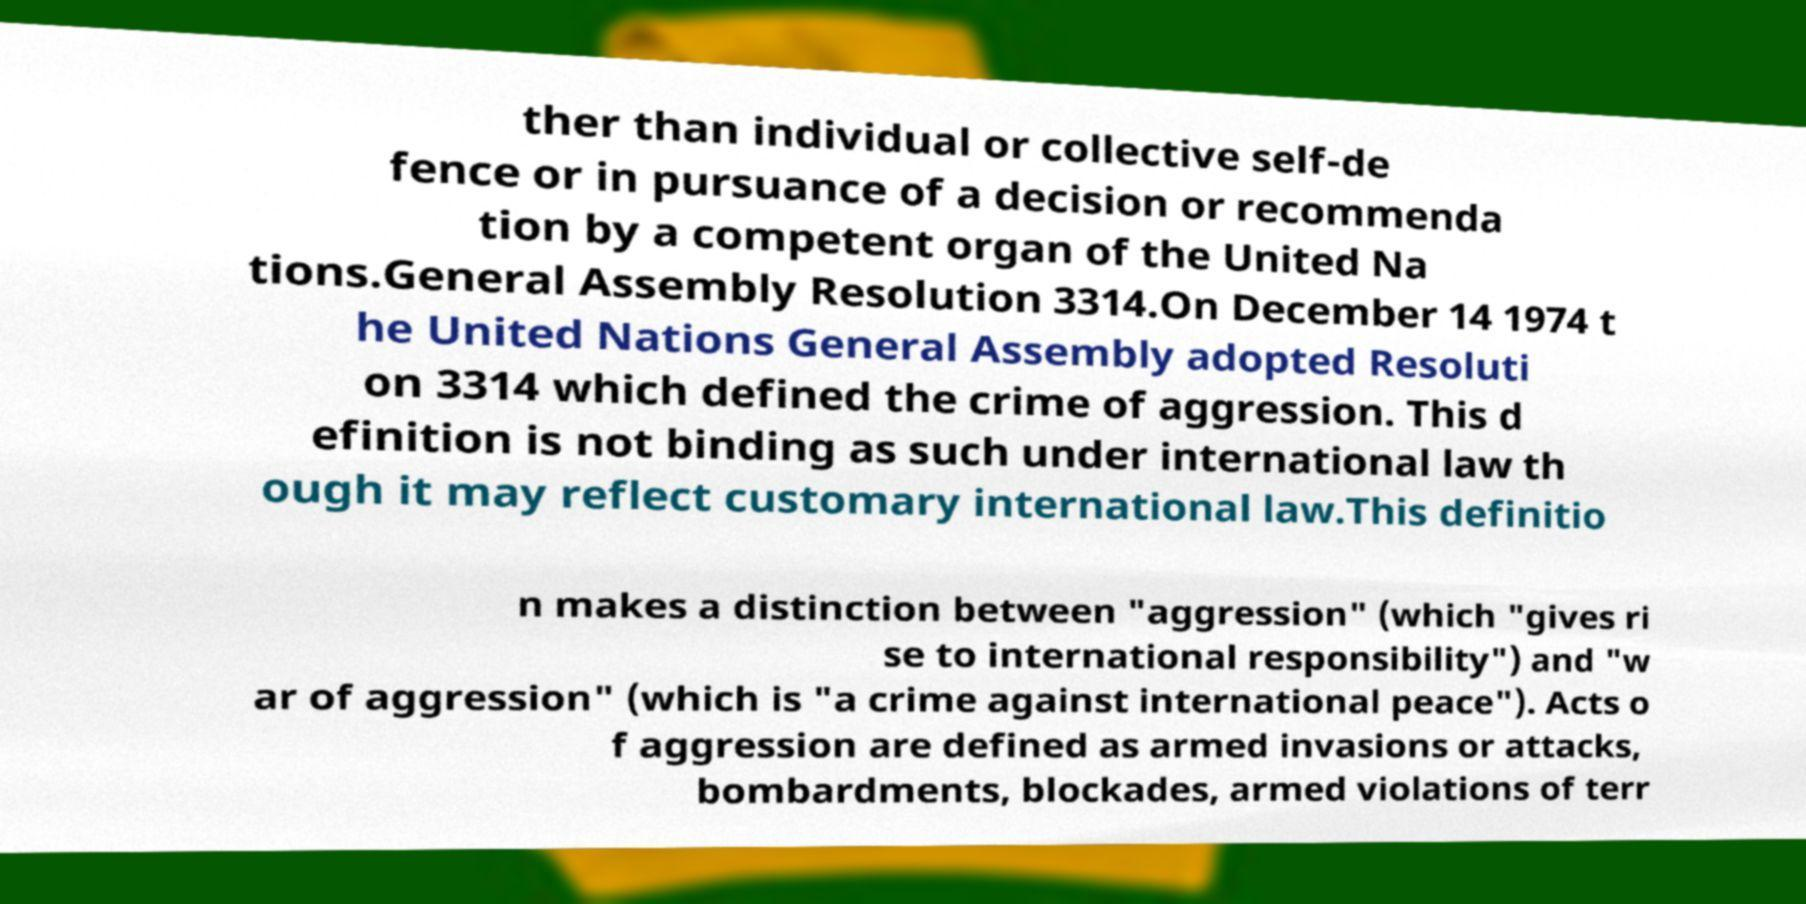Could you extract and type out the text from this image? ther than individual or collective self-de fence or in pursuance of a decision or recommenda tion by a competent organ of the United Na tions.General Assembly Resolution 3314.On December 14 1974 t he United Nations General Assembly adopted Resoluti on 3314 which defined the crime of aggression. This d efinition is not binding as such under international law th ough it may reflect customary international law.This definitio n makes a distinction between "aggression" (which "gives ri se to international responsibility") and "w ar of aggression" (which is "a crime against international peace"). Acts o f aggression are defined as armed invasions or attacks, bombardments, blockades, armed violations of terr 